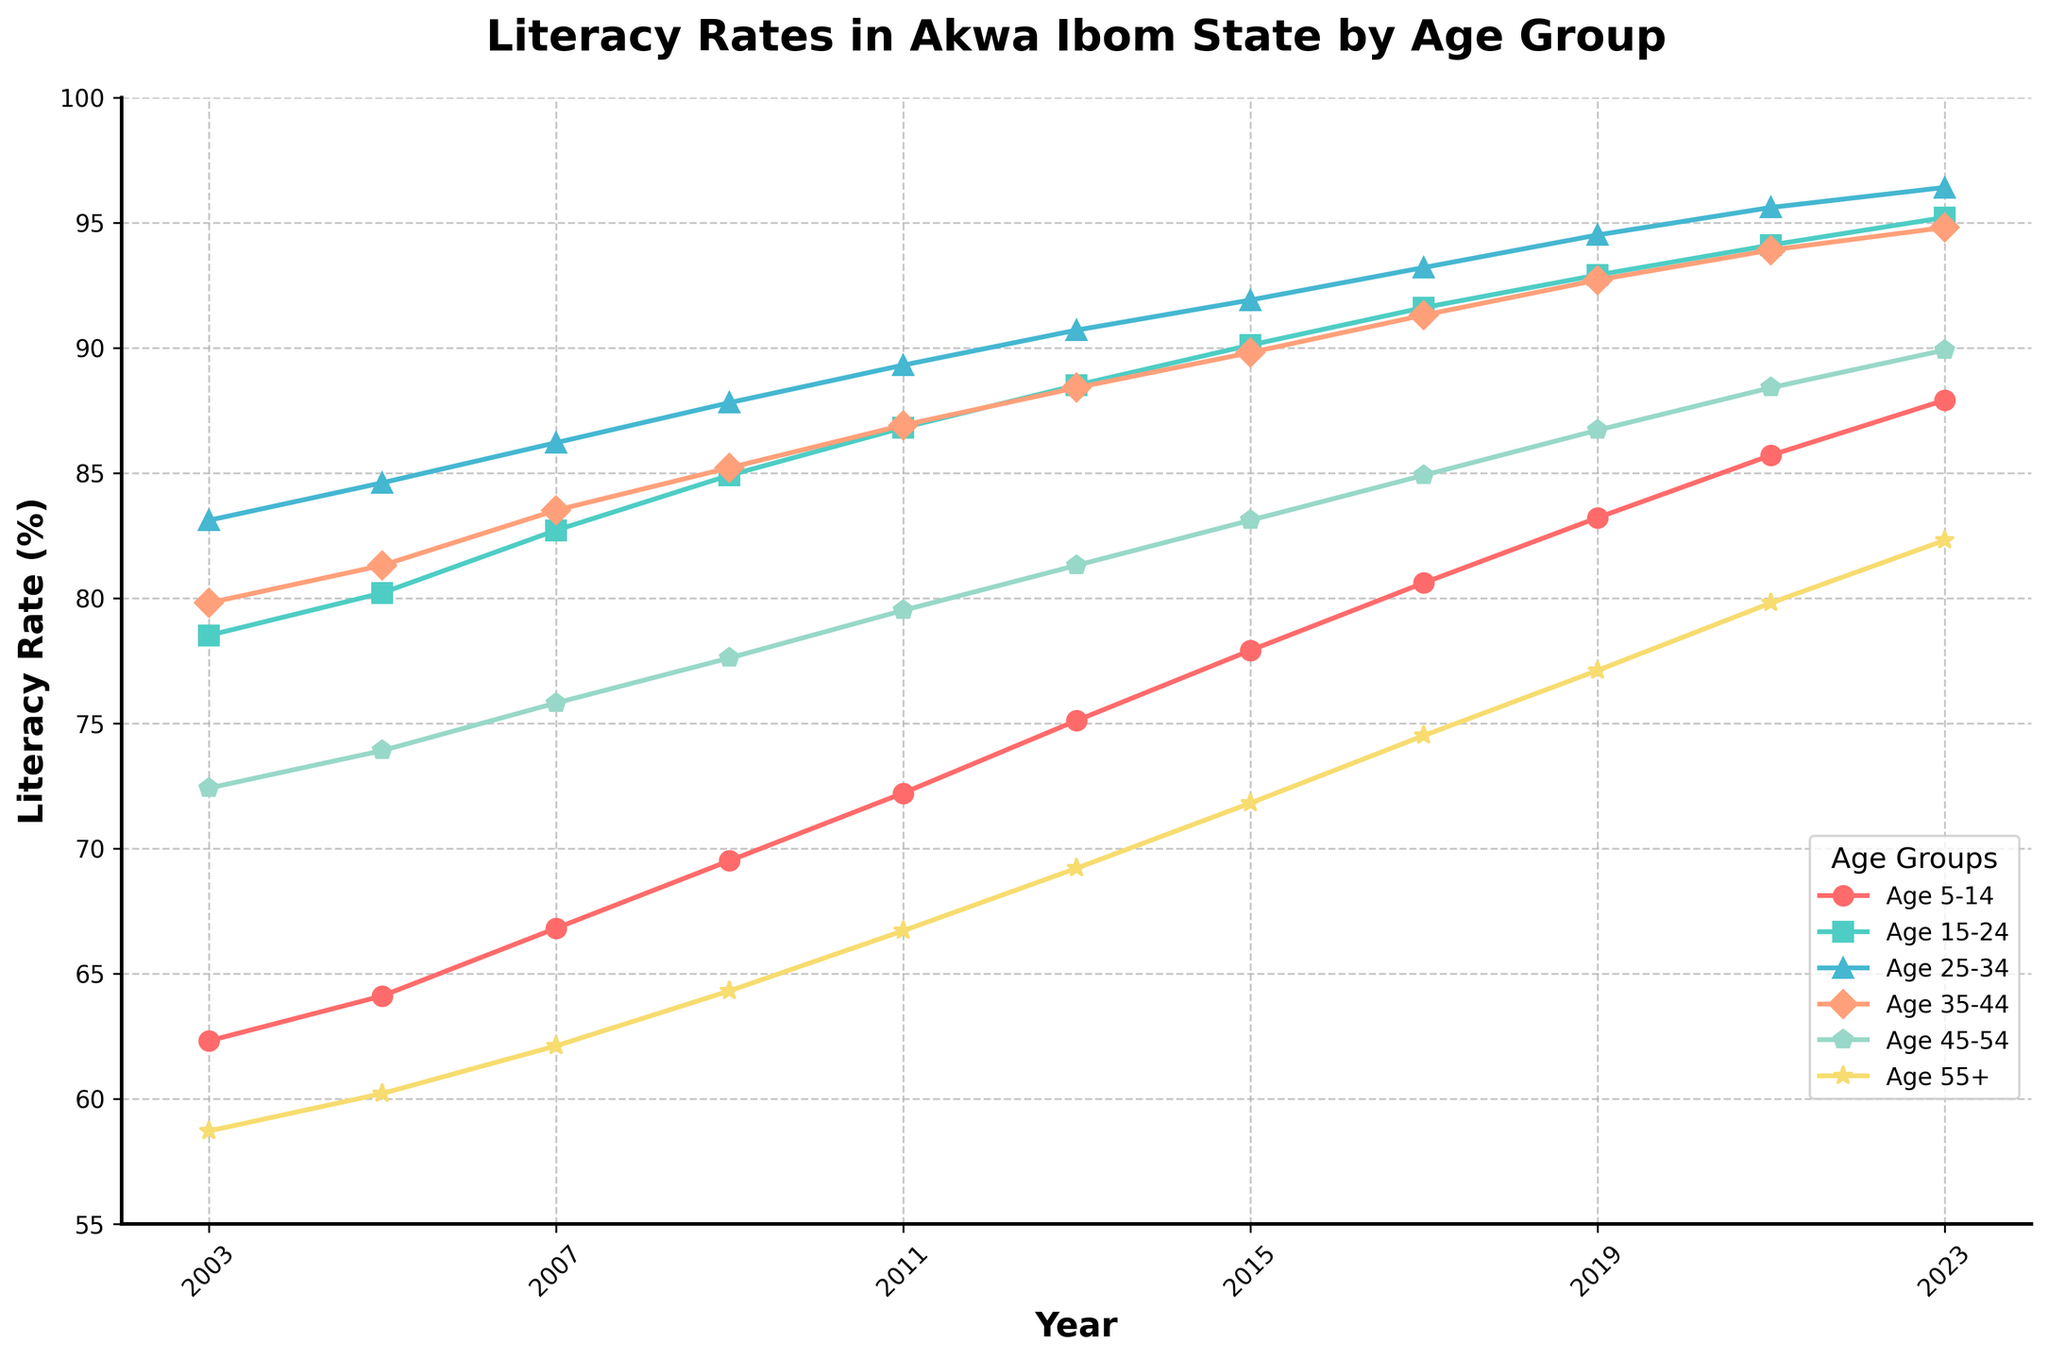What is the literacy rate for the age group 25-34 in 2023? By looking at the line corresponding to the age group 25-34 and its endpoint at the year 2023, we can see the value
Answer: 96.4 Which age group had the lowest literacy rate in 2003? By comparing the heights of the lines at the year 2003, we can see that the age group 55+ had the lowest literacy rate
Answer: 55+ Between 2003 and 2023, which age group showed the largest improvement in literacy rates? Calculate the difference between literacy rates in 2023 and 2003 for each age group: (87.9 - 62.3), (95.2 - 78.5), (96.4 - 83.1), (94.8 - 79.8), (89.9 - 72.4), (82.3 - 58.7). The age group 5-14 shows the greatest improvement
Answer: Age 5-14 In which year did the age group 35-44 surpass a literacy rate of 90%? By following the line for the age group 35-44, we notice that it surpasses 90% at the year 2017
Answer: 2017 What is the average literacy rate for the age group 15-24 over the 20-year period? Sum the literacy rates for Age 15-24 from 2003 to 2023 and then divide by the number of years: (78.5 + 80.2 + 82.7 + 84.9 + 86.8 + 88.5 + 90.1 + 91.6 + 92.9 + 94.1 + 95.2) / 11
Answer: 87.22 Which two age groups had the closest literacy rates in 2021? Compare the literacy rates for all age groups in 2021 to find the pairs with the smallest difference: The values for 25-34 and 35-44 are closest: 95.6 and 93.9 respectively with a difference of 1.7%
Answer: Age 25-34 and Age 35-44 How many age groups had a literacy rate above 90% in 2023? Look at the endpoint in 2023 for each age group and count those with a value above 90%: Age 15-24, 25-34, 35-44, and 45-54
Answer: 4 What is the difference in literacy rates between the age group 55+ in 2003 and 2023? Subtract the literacy rate for 55+ in 2003 from that in 2023: (82.3 - 58.7)
Answer: 23.6 In which years did the literacy rate for the age group 45-54 cross 75%? By following the line corresponding to the age group 45-54 and looking for points where it crosses 75%, we find these are in 2007 and 2009
Answer: 2007 and 2009 